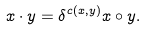Convert formula to latex. <formula><loc_0><loc_0><loc_500><loc_500>x \cdot y = \delta ^ { c ( x , y ) } x \circ y .</formula> 